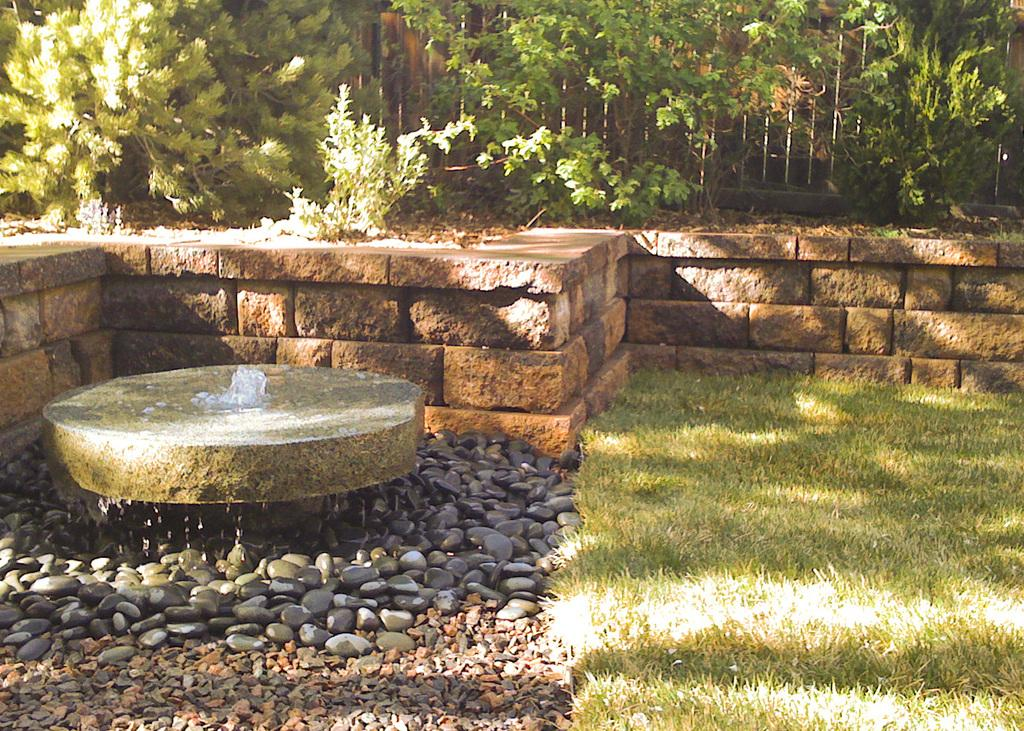What type of vegetation is present in the image? There is grass in the image. What else can be seen besides the grass? There is water and black color stones visible in the image. What is visible in the background of the image? There are trees in the background of the image. What can be observed on the ground in the image? Shadows are visible on the ground in the image. What word is being cried out by the quince in the image? There is no quince or word being cried out in the image; it features in the image include grass, water, black color stones, trees, and shadows. 